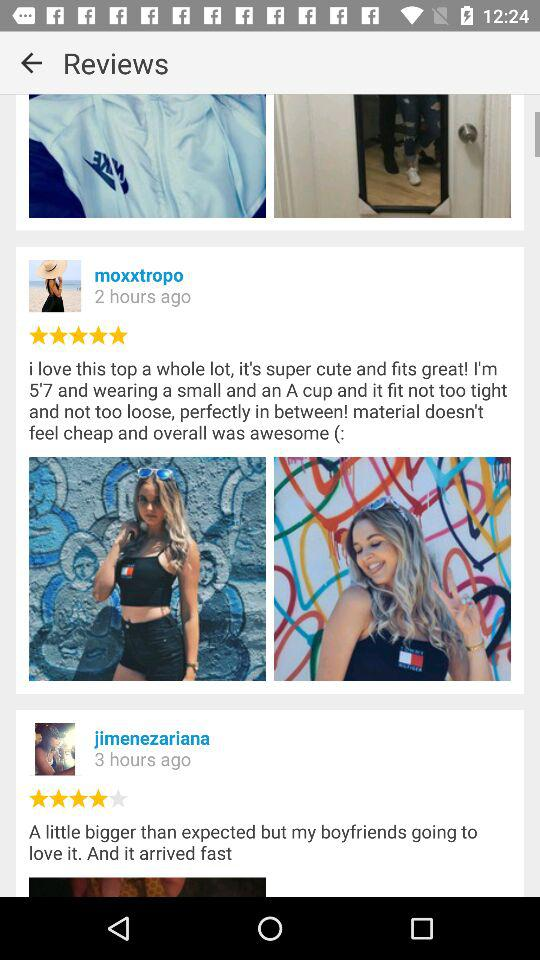What is the name of the application?
When the provided information is insufficient, respond with <no answer>. <no answer> 